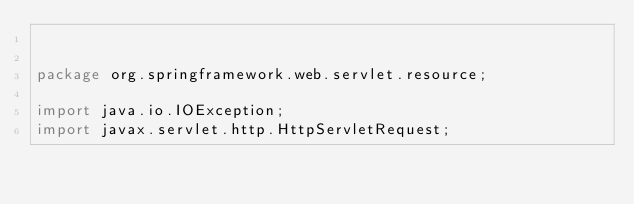<code> <loc_0><loc_0><loc_500><loc_500><_Java_>

package org.springframework.web.servlet.resource;

import java.io.IOException;
import javax.servlet.http.HttpServletRequest;
</code> 